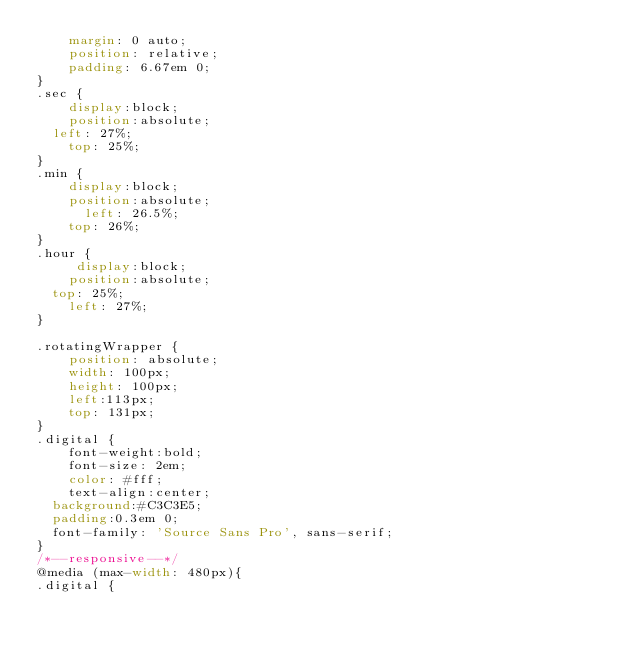<code> <loc_0><loc_0><loc_500><loc_500><_CSS_>    margin: 0 auto;
    position: relative;
    padding: 6.67em 0;
}
.sec {
    display:block;
    position:absolute;
	left: 27%;
    top: 25%;
}
.min {
    display:block;
    position:absolute;
	    left: 26.5%;
    top: 26%;
}
.hour {
     display:block;
    position:absolute;
	top: 25%;
    left: 27%;
}

.rotatingWrapper {
    position: absolute;
    width: 100px;
    height: 100px;
    left:113px;
    top: 131px;
}
.digital {
    font-weight:bold;
    font-size: 2em;
    color: #fff;
    text-align:center;
	background:#C3C3E5;
	padding:0.3em 0;
	font-family: 'Source Sans Pro', sans-serif;
}
/*--responsive--*/
@media (max-width: 480px){
.digital {</code> 